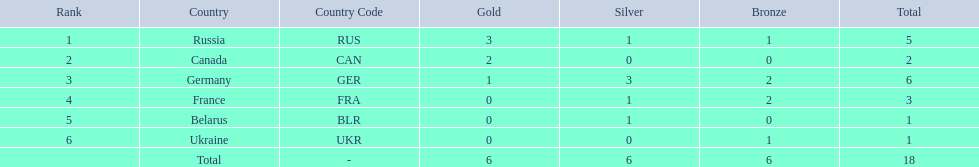Which countries received gold medals? Russia (RUS), Canada (CAN), Germany (GER). Of these countries, which did not receive a silver medal? Canada (CAN). 